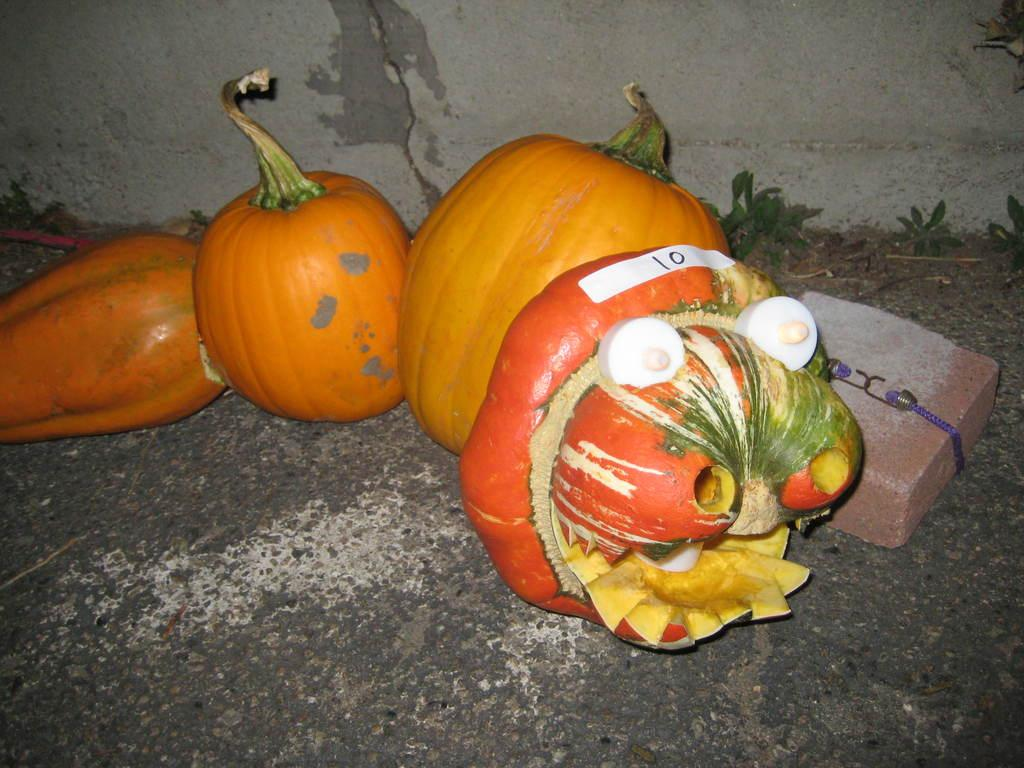What type of vegetable is present in the image? The image contains pumpkins, which are a type of vegetable. What is located at the bottom of the image? There is a road at the bottom of the image. What object can be seen on the right side of the image? There appears to be a brick on the right side of the image. What is visible in the background of the image? There is a wall in the background of the image. What type of notebook is being used by the mother in the image? There is no mother or notebook present in the image. 